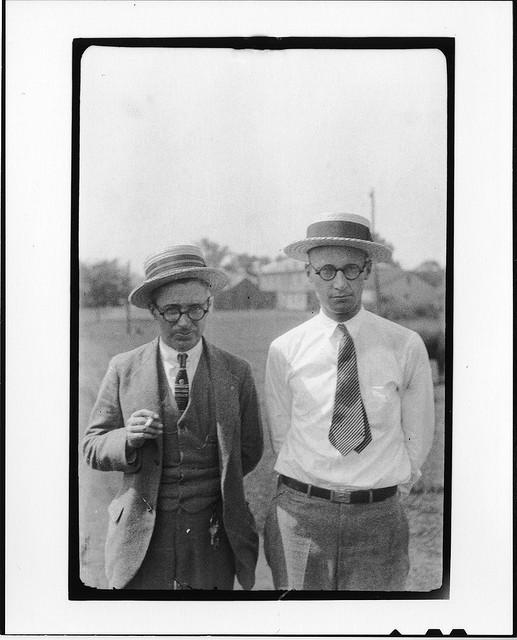Is the tie tied too short or too long?
Keep it brief. Too short. How many people are wearing hats?
Be succinct. 2. What does the man have in his hand?
Keep it brief. Cigarette. Are they both wearing ties?
Answer briefly. Yes. Is this couple married?
Write a very short answer. No. How many pictures?
Give a very brief answer. 1. Who are the narrators?
Concise answer only. Men. What facial expressions are the men wearing?
Answer briefly. Smile. Is this man's tie striped?
Short answer required. Yes. 